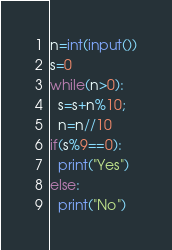Convert code to text. <code><loc_0><loc_0><loc_500><loc_500><_Python_>n=int(input())
s=0
while(n>0):
  s=s+n%10;
  n=n//10
if(s%9==0):
  print("Yes")
else:
  print("No")</code> 